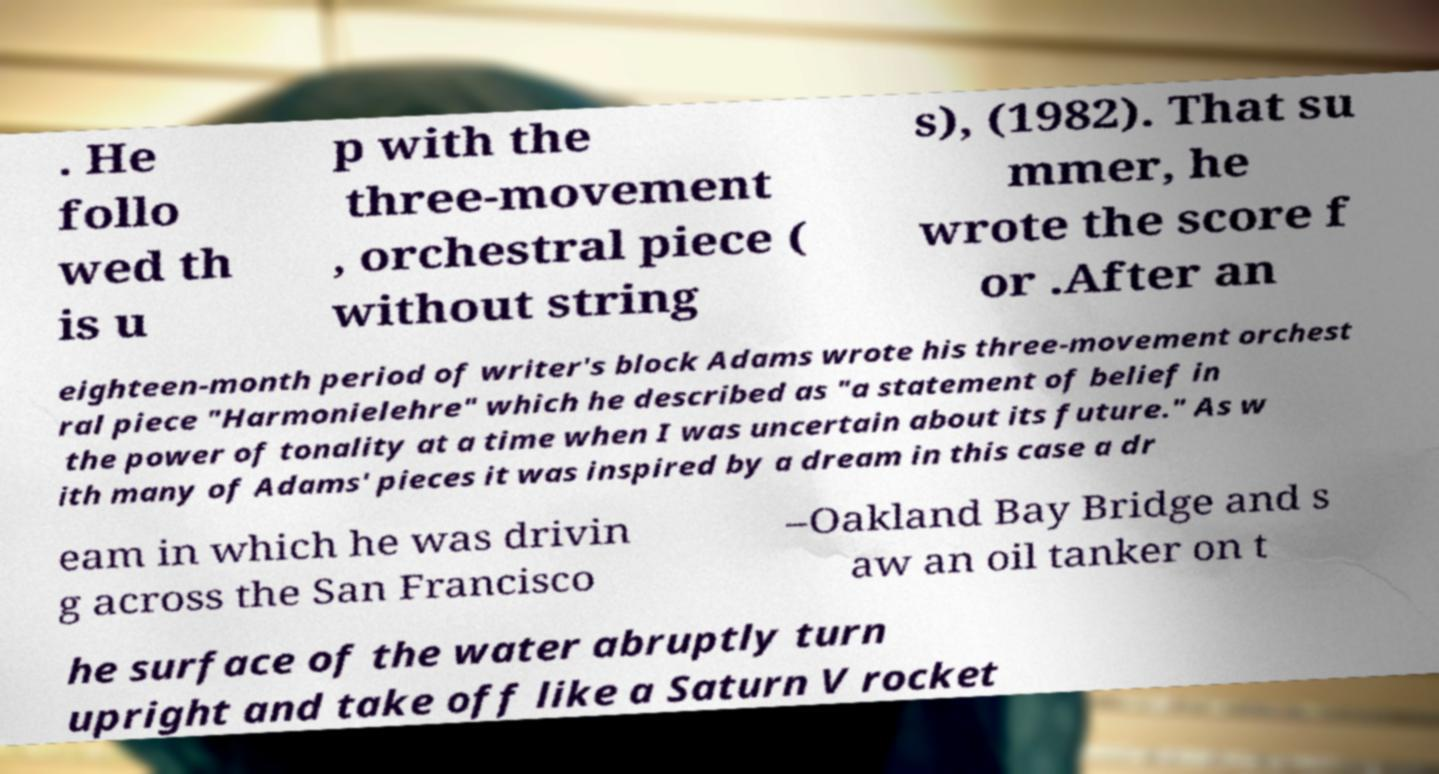I need the written content from this picture converted into text. Can you do that? . He follo wed th is u p with the three-movement , orchestral piece ( without string s), (1982). That su mmer, he wrote the score f or .After an eighteen-month period of writer's block Adams wrote his three-movement orchest ral piece "Harmonielehre" which he described as "a statement of belief in the power of tonality at a time when I was uncertain about its future." As w ith many of Adams' pieces it was inspired by a dream in this case a dr eam in which he was drivin g across the San Francisco –Oakland Bay Bridge and s aw an oil tanker on t he surface of the water abruptly turn upright and take off like a Saturn V rocket 